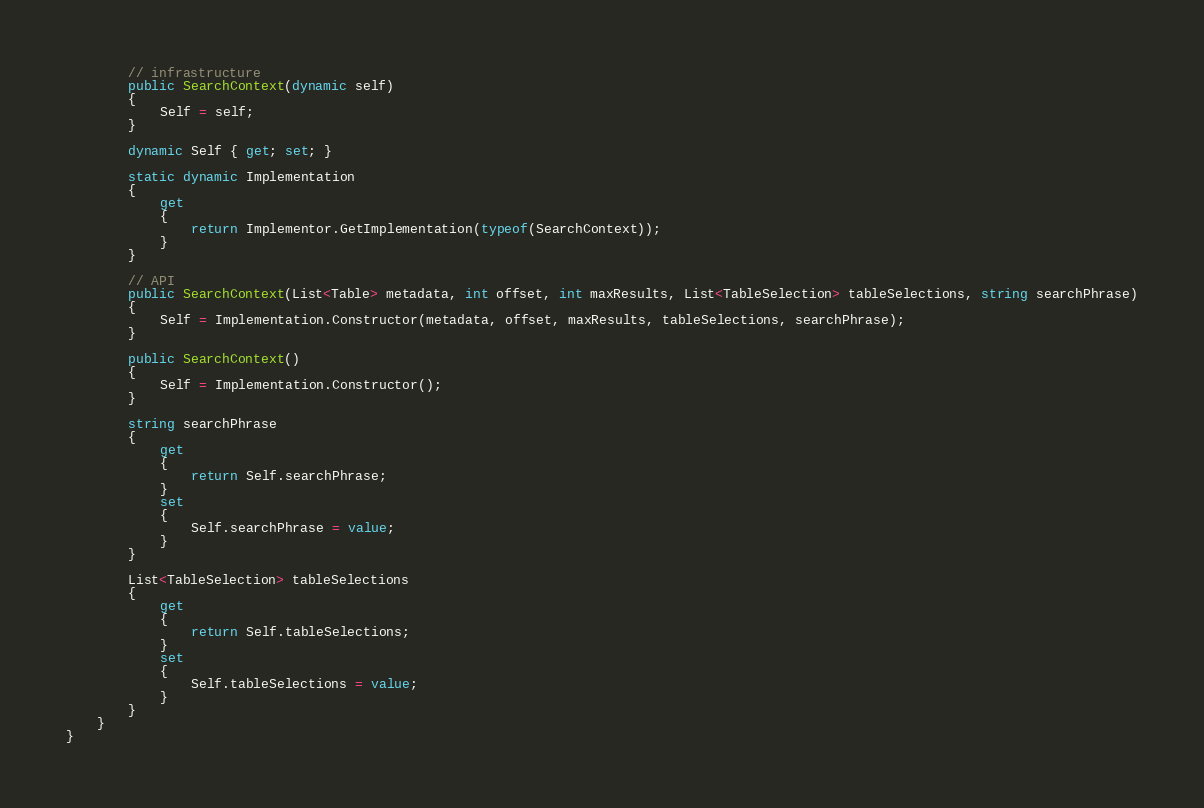Convert code to text. <code><loc_0><loc_0><loc_500><loc_500><_C#_>        // infrastructure
        public SearchContext(dynamic self)
        {
            Self = self;
        }

        dynamic Self { get; set; }

        static dynamic Implementation
        {
            get
            {
                return Implementor.GetImplementation(typeof(SearchContext));
            }
        }

        // API
        public SearchContext(List<Table> metadata, int offset, int maxResults, List<TableSelection> tableSelections, string searchPhrase)
        {
            Self = Implementation.Constructor(metadata, offset, maxResults, tableSelections, searchPhrase);
        }

        public SearchContext()
        {
            Self = Implementation.Constructor();
        }

        string searchPhrase
        {
            get
            {
                return Self.searchPhrase;
            }
            set
            {
                Self.searchPhrase = value;
            }
        }

        List<TableSelection> tableSelections
        {
            get
            {
                return Self.tableSelections;
            }
            set
            {
                Self.tableSelections = value;
            }
        }
    }
}
</code> 